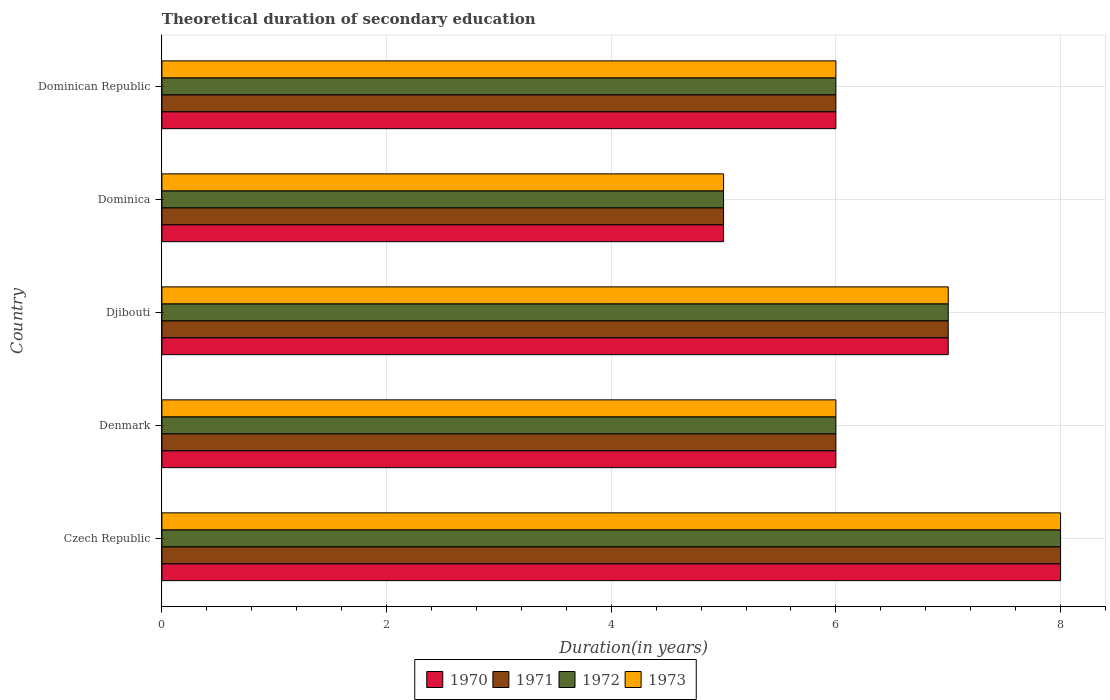How many different coloured bars are there?
Offer a terse response. 4. How many groups of bars are there?
Your answer should be very brief. 5. Are the number of bars per tick equal to the number of legend labels?
Your answer should be very brief. Yes. How many bars are there on the 3rd tick from the top?
Provide a short and direct response. 4. What is the label of the 1st group of bars from the top?
Provide a succinct answer. Dominican Republic. In how many cases, is the number of bars for a given country not equal to the number of legend labels?
Provide a succinct answer. 0. Across all countries, what is the minimum total theoretical duration of secondary education in 1971?
Offer a terse response. 5. In which country was the total theoretical duration of secondary education in 1971 maximum?
Offer a very short reply. Czech Republic. In which country was the total theoretical duration of secondary education in 1972 minimum?
Provide a succinct answer. Dominica. What is the total total theoretical duration of secondary education in 1971 in the graph?
Provide a succinct answer. 32. What is the difference between the total theoretical duration of secondary education in 1970 in Dominican Republic and the total theoretical duration of secondary education in 1972 in Denmark?
Offer a very short reply. 0. What is the average total theoretical duration of secondary education in 1973 per country?
Ensure brevity in your answer.  6.4. What is the difference between the total theoretical duration of secondary education in 1970 and total theoretical duration of secondary education in 1972 in Djibouti?
Provide a short and direct response. 0. What is the ratio of the total theoretical duration of secondary education in 1970 in Czech Republic to that in Djibouti?
Offer a very short reply. 1.14. What is the difference between the highest and the second highest total theoretical duration of secondary education in 1970?
Make the answer very short. 1. In how many countries, is the total theoretical duration of secondary education in 1971 greater than the average total theoretical duration of secondary education in 1971 taken over all countries?
Provide a succinct answer. 2. Is the sum of the total theoretical duration of secondary education in 1971 in Denmark and Dominica greater than the maximum total theoretical duration of secondary education in 1973 across all countries?
Ensure brevity in your answer.  Yes. Is it the case that in every country, the sum of the total theoretical duration of secondary education in 1971 and total theoretical duration of secondary education in 1970 is greater than the sum of total theoretical duration of secondary education in 1972 and total theoretical duration of secondary education in 1973?
Offer a very short reply. No. What does the 3rd bar from the bottom in Dominica represents?
Make the answer very short. 1972. Is it the case that in every country, the sum of the total theoretical duration of secondary education in 1970 and total theoretical duration of secondary education in 1973 is greater than the total theoretical duration of secondary education in 1971?
Offer a very short reply. Yes. Are all the bars in the graph horizontal?
Offer a terse response. Yes. What is the difference between two consecutive major ticks on the X-axis?
Provide a short and direct response. 2. Are the values on the major ticks of X-axis written in scientific E-notation?
Provide a succinct answer. No. Does the graph contain grids?
Your response must be concise. Yes. Where does the legend appear in the graph?
Offer a very short reply. Bottom center. How many legend labels are there?
Give a very brief answer. 4. What is the title of the graph?
Your answer should be compact. Theoretical duration of secondary education. Does "1984" appear as one of the legend labels in the graph?
Provide a short and direct response. No. What is the label or title of the X-axis?
Make the answer very short. Duration(in years). What is the Duration(in years) of 1970 in Czech Republic?
Your answer should be compact. 8. What is the Duration(in years) of 1971 in Czech Republic?
Provide a short and direct response. 8. What is the Duration(in years) in 1972 in Czech Republic?
Your answer should be very brief. 8. What is the Duration(in years) in 1973 in Czech Republic?
Ensure brevity in your answer.  8. What is the Duration(in years) of 1970 in Denmark?
Provide a short and direct response. 6. What is the Duration(in years) of 1971 in Denmark?
Offer a very short reply. 6. What is the Duration(in years) in 1972 in Denmark?
Keep it short and to the point. 6. What is the Duration(in years) in 1970 in Dominica?
Provide a succinct answer. 5. What is the Duration(in years) of 1972 in Dominica?
Your response must be concise. 5. What is the Duration(in years) in 1973 in Dominica?
Offer a terse response. 5. What is the Duration(in years) of 1970 in Dominican Republic?
Give a very brief answer. 6. What is the Duration(in years) in 1973 in Dominican Republic?
Provide a succinct answer. 6. Across all countries, what is the maximum Duration(in years) of 1972?
Ensure brevity in your answer.  8. Across all countries, what is the maximum Duration(in years) of 1973?
Provide a short and direct response. 8. Across all countries, what is the minimum Duration(in years) of 1971?
Provide a short and direct response. 5. Across all countries, what is the minimum Duration(in years) of 1973?
Provide a succinct answer. 5. What is the total Duration(in years) in 1973 in the graph?
Offer a very short reply. 32. What is the difference between the Duration(in years) of 1972 in Czech Republic and that in Denmark?
Make the answer very short. 2. What is the difference between the Duration(in years) in 1970 in Czech Republic and that in Djibouti?
Give a very brief answer. 1. What is the difference between the Duration(in years) in 1972 in Czech Republic and that in Djibouti?
Your answer should be compact. 1. What is the difference between the Duration(in years) in 1973 in Czech Republic and that in Djibouti?
Ensure brevity in your answer.  1. What is the difference between the Duration(in years) in 1971 in Czech Republic and that in Dominica?
Your response must be concise. 3. What is the difference between the Duration(in years) of 1970 in Czech Republic and that in Dominican Republic?
Provide a succinct answer. 2. What is the difference between the Duration(in years) in 1971 in Czech Republic and that in Dominican Republic?
Ensure brevity in your answer.  2. What is the difference between the Duration(in years) in 1972 in Czech Republic and that in Dominican Republic?
Provide a short and direct response. 2. What is the difference between the Duration(in years) in 1970 in Denmark and that in Djibouti?
Keep it short and to the point. -1. What is the difference between the Duration(in years) in 1971 in Denmark and that in Djibouti?
Offer a very short reply. -1. What is the difference between the Duration(in years) of 1973 in Denmark and that in Djibouti?
Offer a very short reply. -1. What is the difference between the Duration(in years) in 1970 in Denmark and that in Dominica?
Keep it short and to the point. 1. What is the difference between the Duration(in years) in 1971 in Denmark and that in Dominica?
Make the answer very short. 1. What is the difference between the Duration(in years) in 1973 in Denmark and that in Dominica?
Make the answer very short. 1. What is the difference between the Duration(in years) in 1970 in Denmark and that in Dominican Republic?
Your answer should be very brief. 0. What is the difference between the Duration(in years) in 1973 in Denmark and that in Dominican Republic?
Make the answer very short. 0. What is the difference between the Duration(in years) of 1970 in Djibouti and that in Dominica?
Make the answer very short. 2. What is the difference between the Duration(in years) in 1971 in Djibouti and that in Dominica?
Ensure brevity in your answer.  2. What is the difference between the Duration(in years) in 1972 in Djibouti and that in Dominica?
Give a very brief answer. 2. What is the difference between the Duration(in years) of 1970 in Djibouti and that in Dominican Republic?
Your answer should be very brief. 1. What is the difference between the Duration(in years) in 1970 in Dominica and that in Dominican Republic?
Your answer should be compact. -1. What is the difference between the Duration(in years) of 1970 in Czech Republic and the Duration(in years) of 1971 in Denmark?
Your response must be concise. 2. What is the difference between the Duration(in years) of 1970 in Czech Republic and the Duration(in years) of 1973 in Denmark?
Provide a succinct answer. 2. What is the difference between the Duration(in years) in 1971 in Czech Republic and the Duration(in years) in 1972 in Denmark?
Make the answer very short. 2. What is the difference between the Duration(in years) in 1971 in Czech Republic and the Duration(in years) in 1973 in Denmark?
Keep it short and to the point. 2. What is the difference between the Duration(in years) in 1972 in Czech Republic and the Duration(in years) in 1973 in Denmark?
Make the answer very short. 2. What is the difference between the Duration(in years) in 1970 in Czech Republic and the Duration(in years) in 1971 in Djibouti?
Your answer should be compact. 1. What is the difference between the Duration(in years) of 1970 in Czech Republic and the Duration(in years) of 1973 in Djibouti?
Provide a succinct answer. 1. What is the difference between the Duration(in years) in 1972 in Czech Republic and the Duration(in years) in 1973 in Djibouti?
Your answer should be very brief. 1. What is the difference between the Duration(in years) in 1970 in Czech Republic and the Duration(in years) in 1971 in Dominica?
Your answer should be very brief. 3. What is the difference between the Duration(in years) of 1970 in Czech Republic and the Duration(in years) of 1973 in Dominica?
Ensure brevity in your answer.  3. What is the difference between the Duration(in years) in 1971 in Czech Republic and the Duration(in years) in 1972 in Dominica?
Provide a short and direct response. 3. What is the difference between the Duration(in years) in 1971 in Czech Republic and the Duration(in years) in 1973 in Dominica?
Give a very brief answer. 3. What is the difference between the Duration(in years) of 1972 in Czech Republic and the Duration(in years) of 1973 in Dominica?
Provide a short and direct response. 3. What is the difference between the Duration(in years) of 1971 in Denmark and the Duration(in years) of 1973 in Djibouti?
Ensure brevity in your answer.  -1. What is the difference between the Duration(in years) of 1970 in Denmark and the Duration(in years) of 1973 in Dominica?
Your answer should be compact. 1. What is the difference between the Duration(in years) in 1972 in Denmark and the Duration(in years) in 1973 in Dominica?
Your answer should be compact. 1. What is the difference between the Duration(in years) in 1970 in Denmark and the Duration(in years) in 1971 in Dominican Republic?
Ensure brevity in your answer.  0. What is the difference between the Duration(in years) in 1970 in Denmark and the Duration(in years) in 1973 in Dominican Republic?
Make the answer very short. 0. What is the difference between the Duration(in years) of 1971 in Denmark and the Duration(in years) of 1973 in Dominican Republic?
Your response must be concise. 0. What is the difference between the Duration(in years) in 1971 in Djibouti and the Duration(in years) in 1972 in Dominica?
Offer a terse response. 2. What is the difference between the Duration(in years) of 1970 in Djibouti and the Duration(in years) of 1971 in Dominican Republic?
Your answer should be compact. 1. What is the difference between the Duration(in years) in 1970 in Djibouti and the Duration(in years) in 1972 in Dominican Republic?
Your answer should be very brief. 1. What is the difference between the Duration(in years) in 1971 in Djibouti and the Duration(in years) in 1972 in Dominican Republic?
Make the answer very short. 1. What is the difference between the Duration(in years) of 1970 in Dominica and the Duration(in years) of 1971 in Dominican Republic?
Make the answer very short. -1. What is the difference between the Duration(in years) in 1970 in Dominica and the Duration(in years) in 1972 in Dominican Republic?
Offer a terse response. -1. What is the difference between the Duration(in years) in 1972 in Dominica and the Duration(in years) in 1973 in Dominican Republic?
Offer a terse response. -1. What is the average Duration(in years) in 1970 per country?
Provide a short and direct response. 6.4. What is the average Duration(in years) in 1971 per country?
Your answer should be very brief. 6.4. What is the difference between the Duration(in years) in 1971 and Duration(in years) in 1972 in Czech Republic?
Offer a very short reply. 0. What is the difference between the Duration(in years) of 1972 and Duration(in years) of 1973 in Czech Republic?
Offer a very short reply. 0. What is the difference between the Duration(in years) of 1970 and Duration(in years) of 1972 in Denmark?
Provide a succinct answer. 0. What is the difference between the Duration(in years) of 1971 and Duration(in years) of 1972 in Denmark?
Offer a terse response. 0. What is the difference between the Duration(in years) of 1971 and Duration(in years) of 1973 in Denmark?
Provide a short and direct response. 0. What is the difference between the Duration(in years) in 1970 and Duration(in years) in 1971 in Djibouti?
Provide a succinct answer. 0. What is the difference between the Duration(in years) of 1970 and Duration(in years) of 1972 in Djibouti?
Give a very brief answer. 0. What is the difference between the Duration(in years) in 1970 and Duration(in years) in 1973 in Djibouti?
Ensure brevity in your answer.  0. What is the difference between the Duration(in years) in 1972 and Duration(in years) in 1973 in Djibouti?
Offer a terse response. 0. What is the difference between the Duration(in years) of 1970 and Duration(in years) of 1972 in Dominica?
Your response must be concise. 0. What is the difference between the Duration(in years) of 1971 and Duration(in years) of 1972 in Dominica?
Offer a very short reply. 0. What is the difference between the Duration(in years) of 1971 and Duration(in years) of 1973 in Dominica?
Ensure brevity in your answer.  0. What is the difference between the Duration(in years) in 1970 and Duration(in years) in 1971 in Dominican Republic?
Give a very brief answer. 0. What is the difference between the Duration(in years) of 1971 and Duration(in years) of 1973 in Dominican Republic?
Make the answer very short. 0. What is the ratio of the Duration(in years) of 1970 in Czech Republic to that in Denmark?
Your answer should be compact. 1.33. What is the ratio of the Duration(in years) of 1971 in Czech Republic to that in Denmark?
Your answer should be very brief. 1.33. What is the ratio of the Duration(in years) of 1973 in Czech Republic to that in Dominica?
Give a very brief answer. 1.6. What is the ratio of the Duration(in years) in 1971 in Czech Republic to that in Dominican Republic?
Give a very brief answer. 1.33. What is the ratio of the Duration(in years) in 1970 in Denmark to that in Djibouti?
Provide a succinct answer. 0.86. What is the ratio of the Duration(in years) of 1973 in Denmark to that in Djibouti?
Make the answer very short. 0.86. What is the ratio of the Duration(in years) in 1971 in Denmark to that in Dominica?
Your answer should be compact. 1.2. What is the ratio of the Duration(in years) in 1973 in Denmark to that in Dominica?
Give a very brief answer. 1.2. What is the ratio of the Duration(in years) in 1971 in Denmark to that in Dominican Republic?
Your response must be concise. 1. What is the ratio of the Duration(in years) in 1972 in Denmark to that in Dominican Republic?
Give a very brief answer. 1. What is the ratio of the Duration(in years) of 1970 in Djibouti to that in Dominica?
Offer a terse response. 1.4. What is the ratio of the Duration(in years) of 1971 in Djibouti to that in Dominica?
Your answer should be very brief. 1.4. What is the ratio of the Duration(in years) of 1973 in Djibouti to that in Dominica?
Your answer should be compact. 1.4. What is the ratio of the Duration(in years) of 1971 in Djibouti to that in Dominican Republic?
Offer a very short reply. 1.17. What is the ratio of the Duration(in years) in 1970 in Dominica to that in Dominican Republic?
Keep it short and to the point. 0.83. What is the ratio of the Duration(in years) of 1971 in Dominica to that in Dominican Republic?
Give a very brief answer. 0.83. What is the difference between the highest and the second highest Duration(in years) of 1972?
Your answer should be compact. 1. What is the difference between the highest and the second highest Duration(in years) of 1973?
Offer a very short reply. 1. What is the difference between the highest and the lowest Duration(in years) in 1970?
Offer a terse response. 3. 